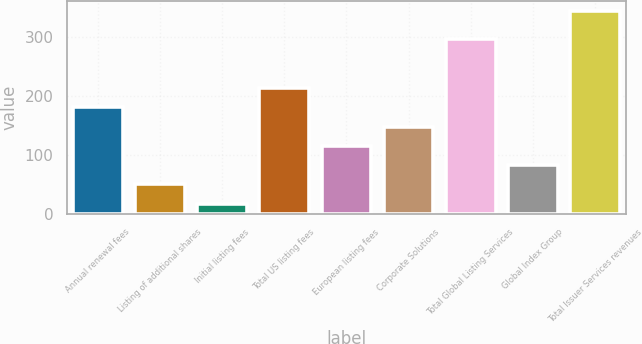Convert chart to OTSL. <chart><loc_0><loc_0><loc_500><loc_500><bar_chart><fcel>Annual renewal fees<fcel>Listing of additional shares<fcel>Initial listing fees<fcel>Total US listing fees<fcel>European listing fees<fcel>Corporate Solutions<fcel>Total Global Listing Services<fcel>Global Index Group<fcel>Total Issuer Services revenues<nl><fcel>181<fcel>50.6<fcel>18<fcel>213.6<fcel>115.8<fcel>148.4<fcel>297<fcel>83.2<fcel>344<nl></chart> 